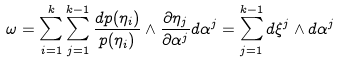<formula> <loc_0><loc_0><loc_500><loc_500>\omega = \sum _ { i = 1 } ^ { k } \sum _ { j = 1 } ^ { k - 1 } \frac { d p ( \eta _ { i } ) } { p ( \eta _ { i } ) } \wedge \frac { \partial \eta _ { j } } { \partial \alpha ^ { j } } d \alpha ^ { j } = \sum _ { j = 1 } ^ { k - 1 } d \xi ^ { j } \wedge d \alpha ^ { j }</formula> 